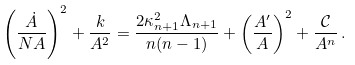Convert formula to latex. <formula><loc_0><loc_0><loc_500><loc_500>\left ( \frac { \dot { A } } { N A } \right ) ^ { 2 } + \frac { k } { A ^ { 2 } } = \frac { 2 \kappa _ { n + 1 } ^ { 2 } \Lambda _ { n + 1 } } { n ( n - 1 ) } + \left ( \frac { A ^ { \prime } } { A } \right ) ^ { 2 } + \frac { \mathcal { C } } { A ^ { n } } \, .</formula> 